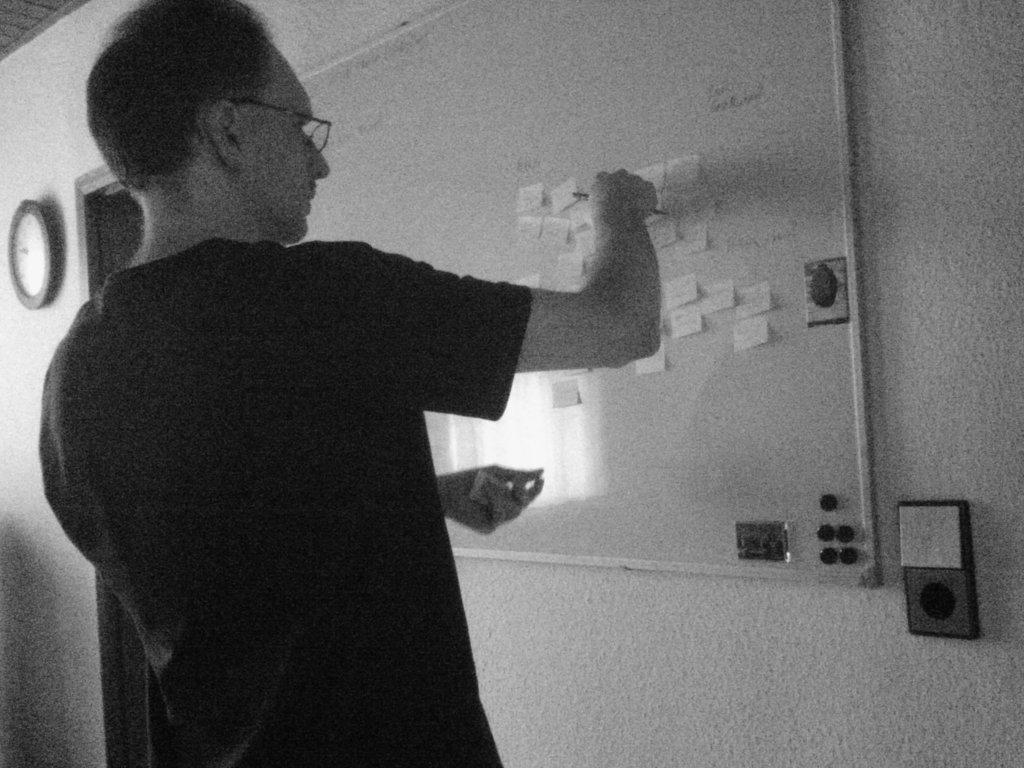In one or two sentences, can you explain what this image depicts? This is a black and picture of a man standing in front of board and sticking notes to it, on the left side there is a clock on the wall. 